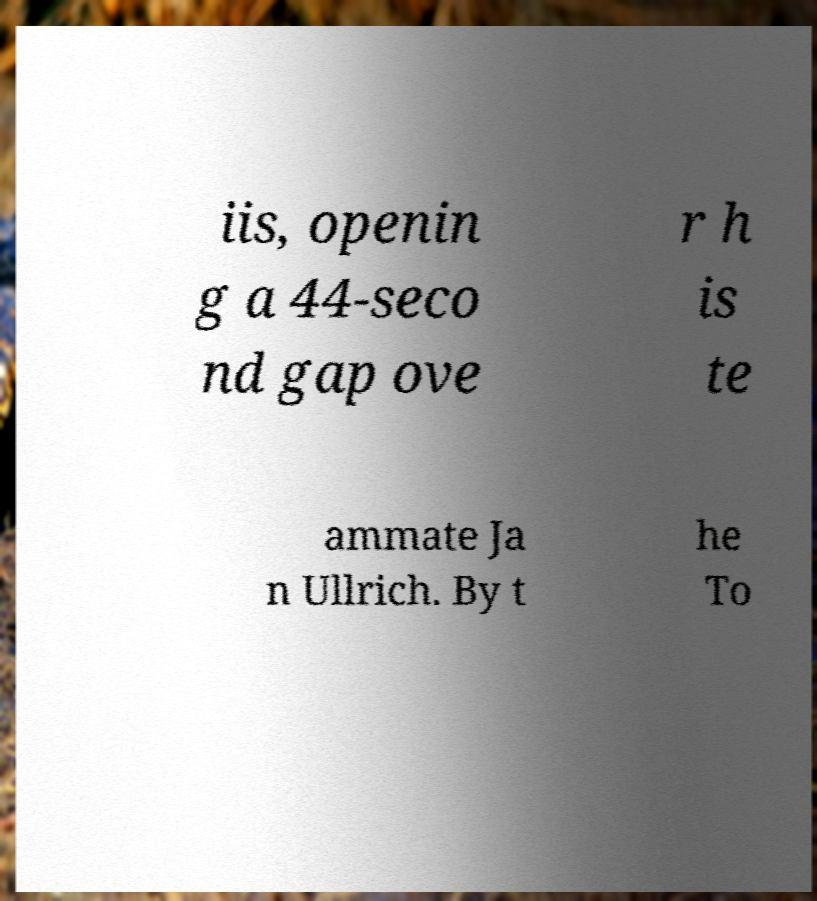Please identify and transcribe the text found in this image. iis, openin g a 44-seco nd gap ove r h is te ammate Ja n Ullrich. By t he To 